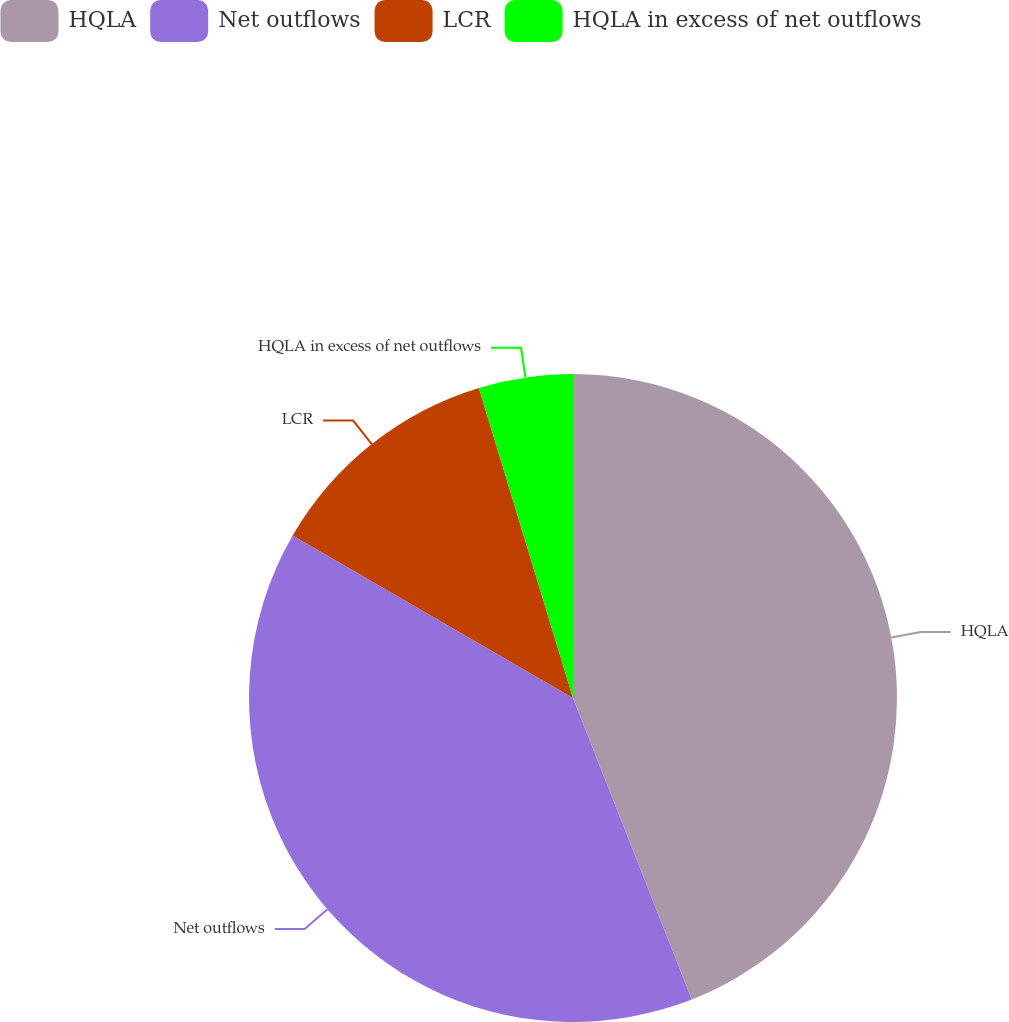Convert chart to OTSL. <chart><loc_0><loc_0><loc_500><loc_500><pie_chart><fcel>HQLA<fcel>Net outflows<fcel>LCR<fcel>HQLA in excess of net outflows<nl><fcel>44.02%<fcel>39.33%<fcel>11.95%<fcel>4.69%<nl></chart> 